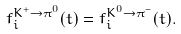<formula> <loc_0><loc_0><loc_500><loc_500>f _ { i } ^ { K ^ { + } \rightarrow \pi ^ { 0 } } ( t ) = f _ { i } ^ { K ^ { 0 } \rightarrow \pi ^ { - } } ( t ) .</formula> 